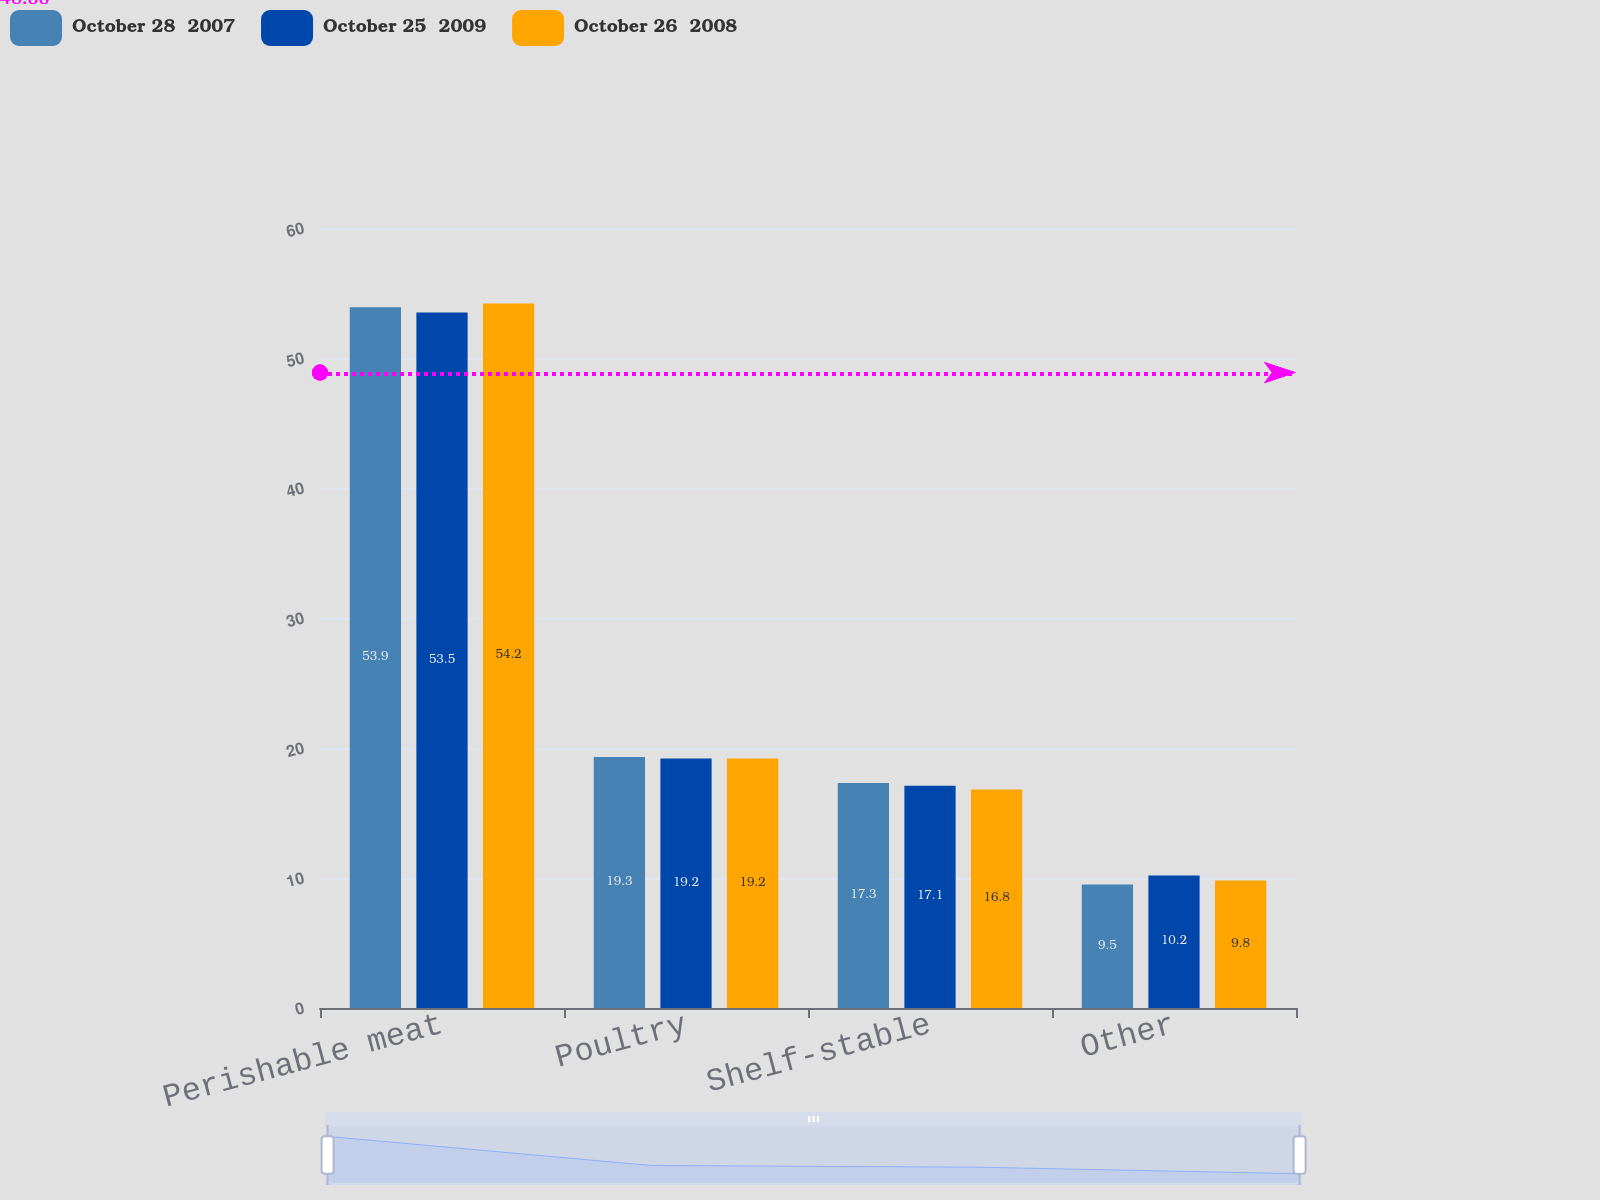<chart> <loc_0><loc_0><loc_500><loc_500><stacked_bar_chart><ecel><fcel>Perishable meat<fcel>Poultry<fcel>Shelf-stable<fcel>Other<nl><fcel>October 28  2007<fcel>53.9<fcel>19.3<fcel>17.3<fcel>9.5<nl><fcel>October 25  2009<fcel>53.5<fcel>19.2<fcel>17.1<fcel>10.2<nl><fcel>October 26  2008<fcel>54.2<fcel>19.2<fcel>16.8<fcel>9.8<nl></chart> 